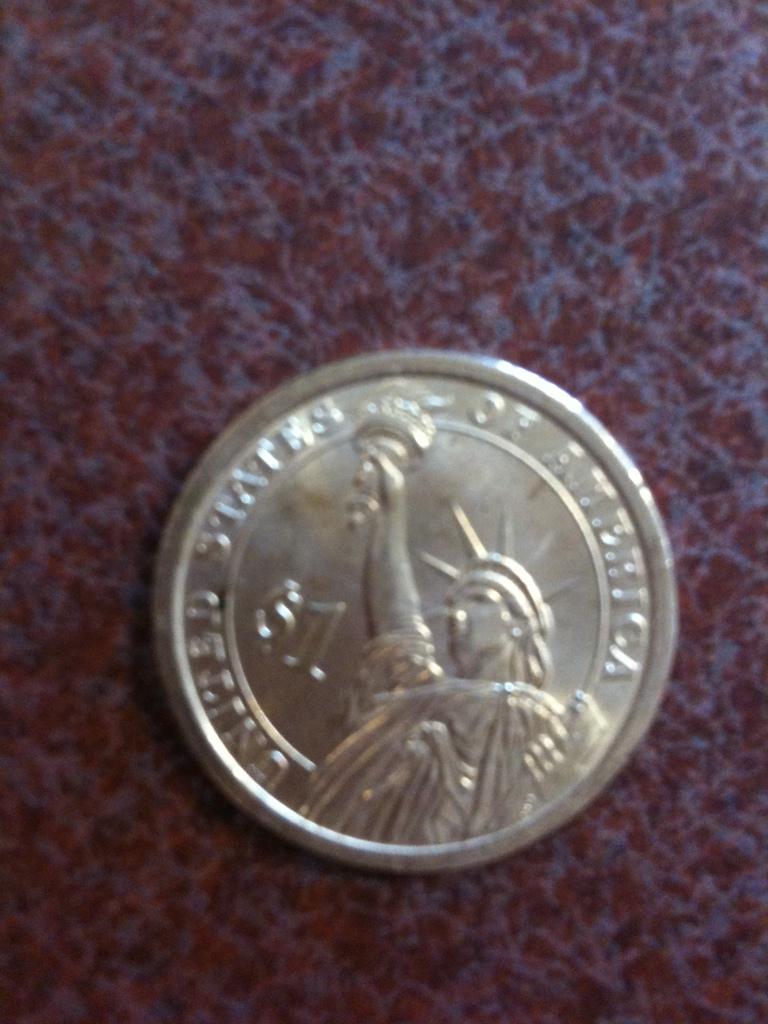How much is the coin worth?
Make the answer very short. $1. United states od who?
Make the answer very short. America. 